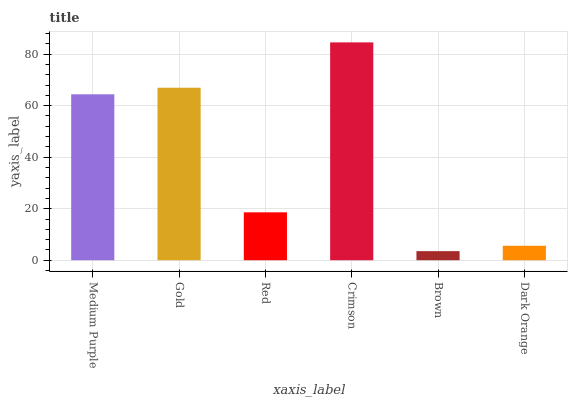Is Brown the minimum?
Answer yes or no. Yes. Is Crimson the maximum?
Answer yes or no. Yes. Is Gold the minimum?
Answer yes or no. No. Is Gold the maximum?
Answer yes or no. No. Is Gold greater than Medium Purple?
Answer yes or no. Yes. Is Medium Purple less than Gold?
Answer yes or no. Yes. Is Medium Purple greater than Gold?
Answer yes or no. No. Is Gold less than Medium Purple?
Answer yes or no. No. Is Medium Purple the high median?
Answer yes or no. Yes. Is Red the low median?
Answer yes or no. Yes. Is Crimson the high median?
Answer yes or no. No. Is Crimson the low median?
Answer yes or no. No. 